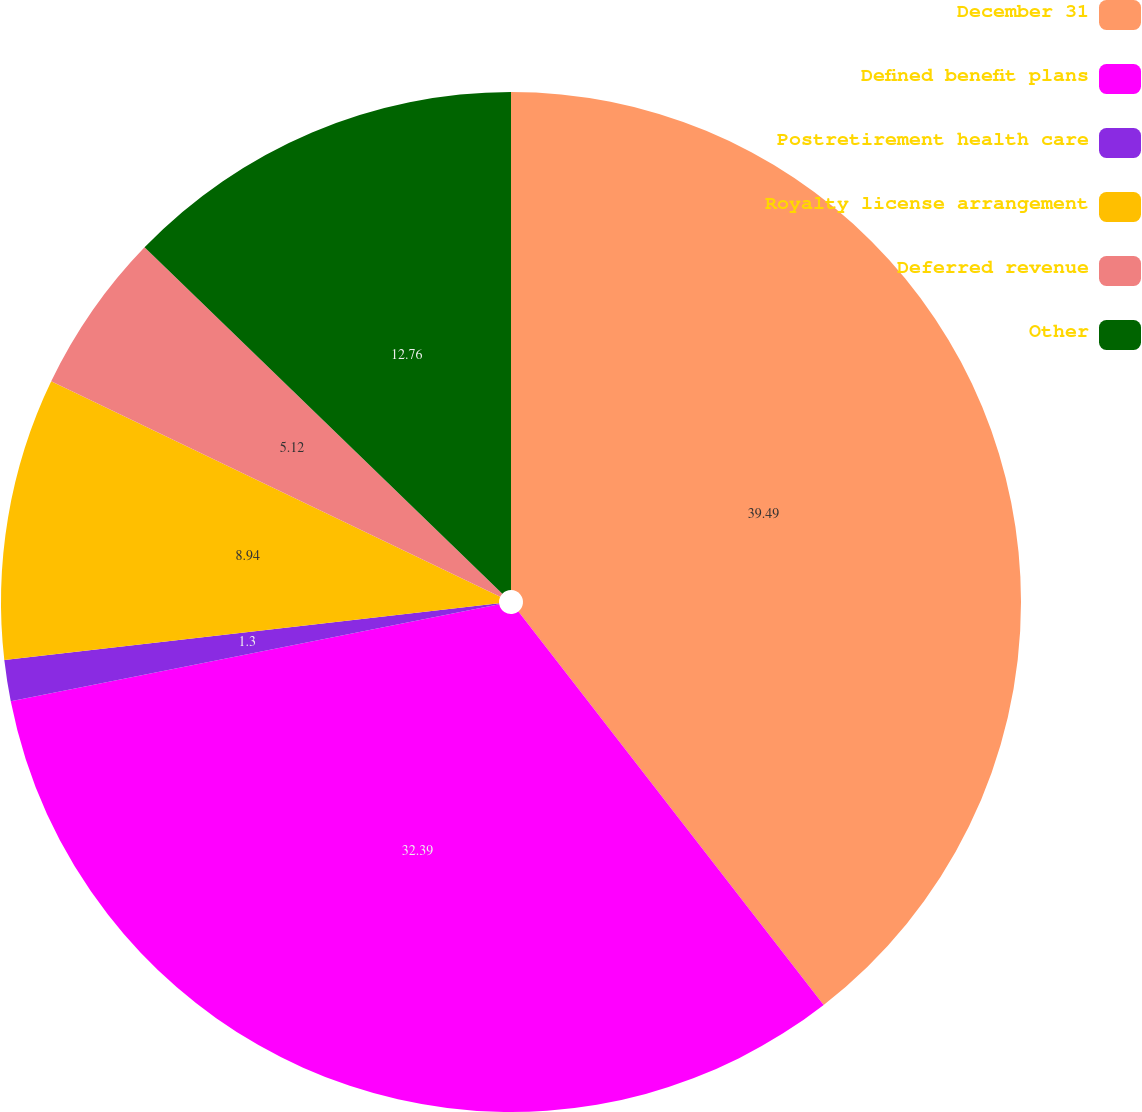<chart> <loc_0><loc_0><loc_500><loc_500><pie_chart><fcel>December 31<fcel>Defined benefit plans<fcel>Postretirement health care<fcel>Royalty license arrangement<fcel>Deferred revenue<fcel>Other<nl><fcel>39.5%<fcel>32.39%<fcel>1.3%<fcel>8.94%<fcel>5.12%<fcel>12.76%<nl></chart> 